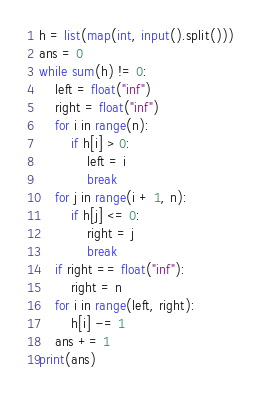<code> <loc_0><loc_0><loc_500><loc_500><_Python_>h = list(map(int, input().split()))
ans = 0
while sum(h) != 0:
    left = float("inf")
    right = float("inf")
    for i in range(n):
        if h[i] > 0:
            left = i
            break
    for j in range(i + 1, n):
        if h[j] <= 0:
            right = j
            break
    if right == float("inf"):
        right = n
    for i in range(left, right):
        h[i] -= 1
    ans += 1
print(ans)</code> 